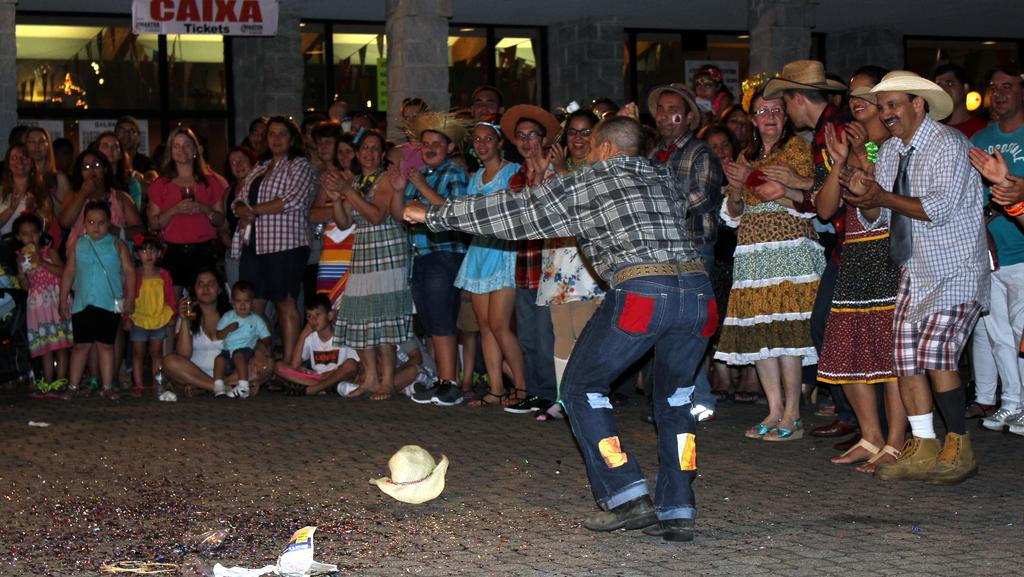What is the main subject in the foreground of the image? There is a man in the foreground of the image. What is the man wearing in the image? The man is wearing a hat. What is the position of the hat in the image? The hat is on the floor. What are the people in the image doing? The people are clapping. What can be seen in the background of the image? There are posters and it appears there are windows in the background of the image. What is the source of light in the image? There is light visible in the image. What type of hill can be seen in the background of the image? There is no hill visible in the image; it appears there are windows in the background. What event is taking place in the image? The image does not provide enough information to determine the specific event taking place, as it only shows a man, a hat, people clapping, and posters in the background. 